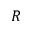<formula> <loc_0><loc_0><loc_500><loc_500>R</formula> 